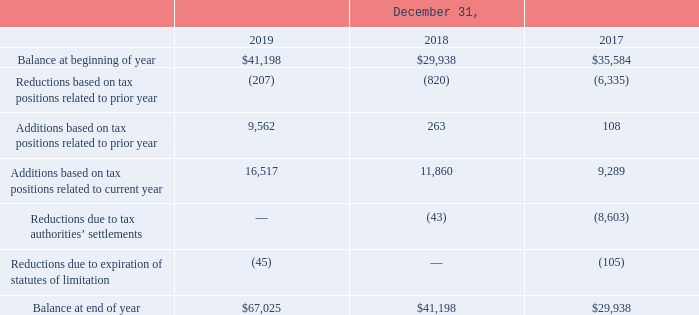Utilization of the net operating loss and tax credit carry forwards are subject to an annual limitation due to the ownership percentage change limitations provided by the Internal Revenue Code of 1986 and similar state provisions. The annual limitation may result in the expiration of the net operating loss before utilization. The Company does not expect the limitation to result in a reduction in the total amount utilizable.
The Company is subject to income taxes in the U.S. (federal and state) and numerous foreign jurisdictions. Significant judgment is required in evaluating the Company’s tax positions and determining its provision for income taxes. During the ordinary course of business, there are many transactions and calculations for which the ultimate tax determination is uncertain. The Company establishes reserves for tax-related uncertainties based on estimates of whether, and the extent to which, additional taxes will be due. These reserves are established when the Company believes that certain positions might be challenged despite its belief that its tax return positions are fully supportable. The Company adjusts these reserves in light of changing facts and circumstances, such as the outcome of tax audits. The provision for income taxes includes the impact of reserve provisions and changes to reserves that are considered appropriate. As of December 31, 2019 and 2018, the Company had $67.0 million and $41.2 million of unrecognized tax benefits, respectively. A reconciliation of the beginning and ending amount of unrecognized tax benefits is as follows (in thousands):
At December 31, 2019, the total amount of gross unrecognized tax benefits was $67.0 million, of which $31.9 million would affect the Company’s effective tax rate if recognized. The Company does not have any tax positions as of December 31, 2019 for which it is reasonably possible the total amount of gross unrecognized tax benefits will increase or decrease within the following 12 months. The Company’s policy is to record interest and penalties related to unrecognized tax benefits as income tax expense. As of December 31, 2019 and 2018, respectively, the Company has accrued $5.2 million and $3.1 million related to interest and penalties, respectively.
The material jurisdictions in which the Company is subject to potential examination include the United States and Ireland. The Company believes that adequate amounts have been reserved for these jurisdictions. For the United States, the Company is currently under examination by the Internal Revenue Service ("IRS") for fiscal 2015 to 2017. For state and non-U.S. tax returns, the Company is generally no longer subject to tax examinations for years prior to 2014.
Under the company's policy, what is recorded as income tax expense? Interest and penalties related to unrecognized tax benefits. What is the amount related to interest and penalties as of December 31, 2018? $3.1 million. At what years is the Company in the United States under examination by the Internal Revenue Service? Fiscal 2015 to 2017. What is the average additions based on tax positions related to prior year from 2017-2019?
Answer scale should be: thousand. (9,562+263+108)/3
Answer: 3311. What is the difference in the balance at end of year between 2018 and 2019?
Answer scale should be: thousand. 67,025-41,198
Answer: 25827. What is the percentage change of additions based on tax positions related to current year from 2018 to 2019?
Answer scale should be: percent. (16,517-11,860)/11,860
Answer: 39.27. 